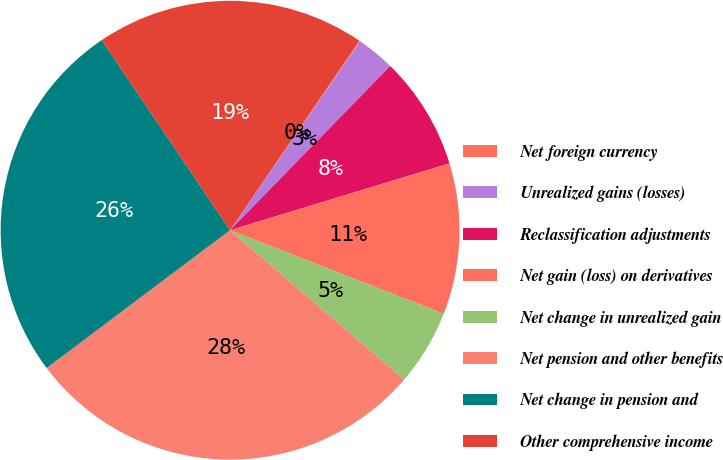Convert chart. <chart><loc_0><loc_0><loc_500><loc_500><pie_chart><fcel>Net foreign currency<fcel>Unrealized gains (losses)<fcel>Reclassification adjustments<fcel>Net gain (loss) on derivatives<fcel>Net change in unrealized gain<fcel>Net pension and other benefits<fcel>Net change in pension and<fcel>Other comprehensive income<nl><fcel>0.06%<fcel>2.71%<fcel>7.99%<fcel>10.64%<fcel>5.35%<fcel>28.46%<fcel>25.81%<fcel>18.98%<nl></chart> 